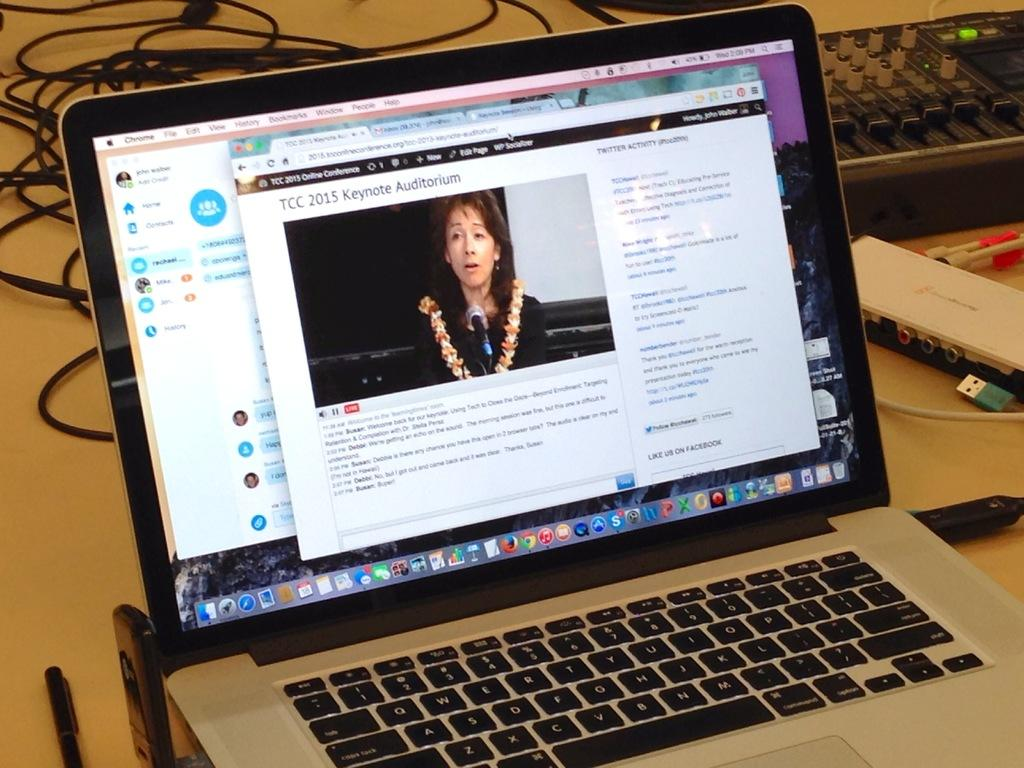<image>
Create a compact narrative representing the image presented. a mac laptop open to the TCC 2015 Keynote Auditorium 